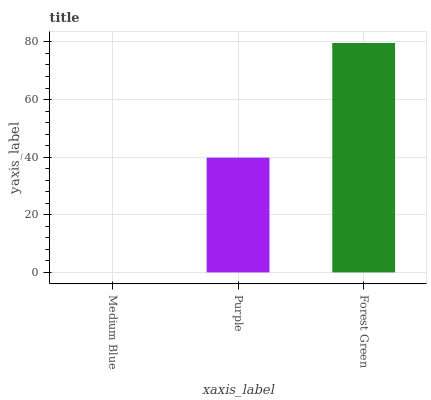Is Medium Blue the minimum?
Answer yes or no. Yes. Is Forest Green the maximum?
Answer yes or no. Yes. Is Purple the minimum?
Answer yes or no. No. Is Purple the maximum?
Answer yes or no. No. Is Purple greater than Medium Blue?
Answer yes or no. Yes. Is Medium Blue less than Purple?
Answer yes or no. Yes. Is Medium Blue greater than Purple?
Answer yes or no. No. Is Purple less than Medium Blue?
Answer yes or no. No. Is Purple the high median?
Answer yes or no. Yes. Is Purple the low median?
Answer yes or no. Yes. Is Forest Green the high median?
Answer yes or no. No. Is Medium Blue the low median?
Answer yes or no. No. 